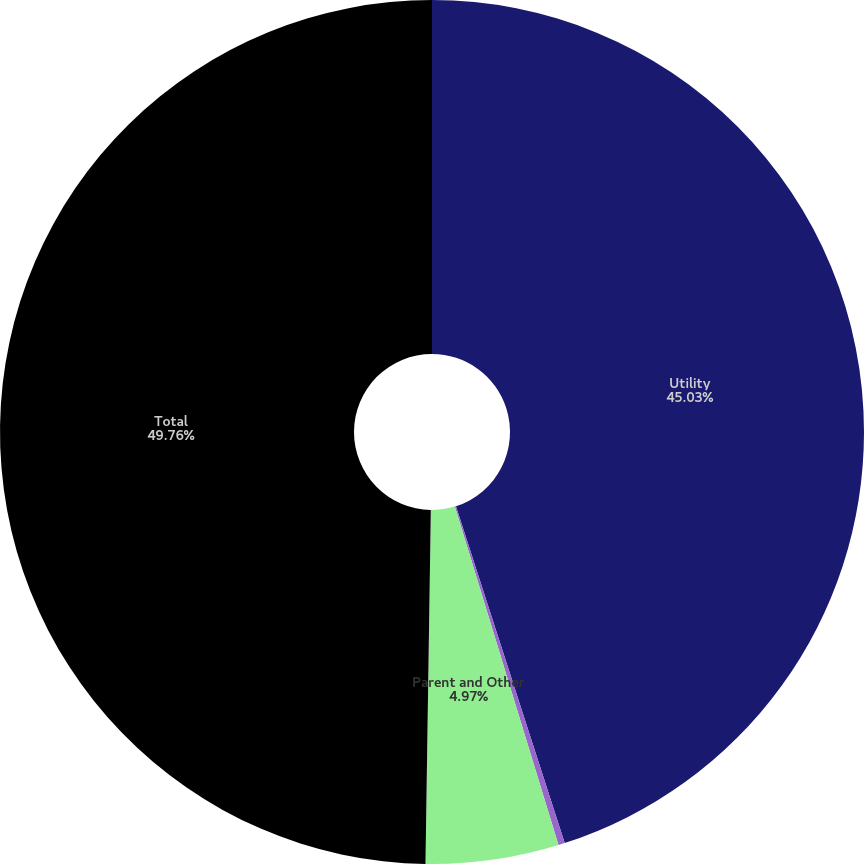Convert chart. <chart><loc_0><loc_0><loc_500><loc_500><pie_chart><fcel>Utility<fcel>Entergy Wholesale Commodities<fcel>Parent and Other<fcel>Total<nl><fcel>45.03%<fcel>0.24%<fcel>4.97%<fcel>49.76%<nl></chart> 